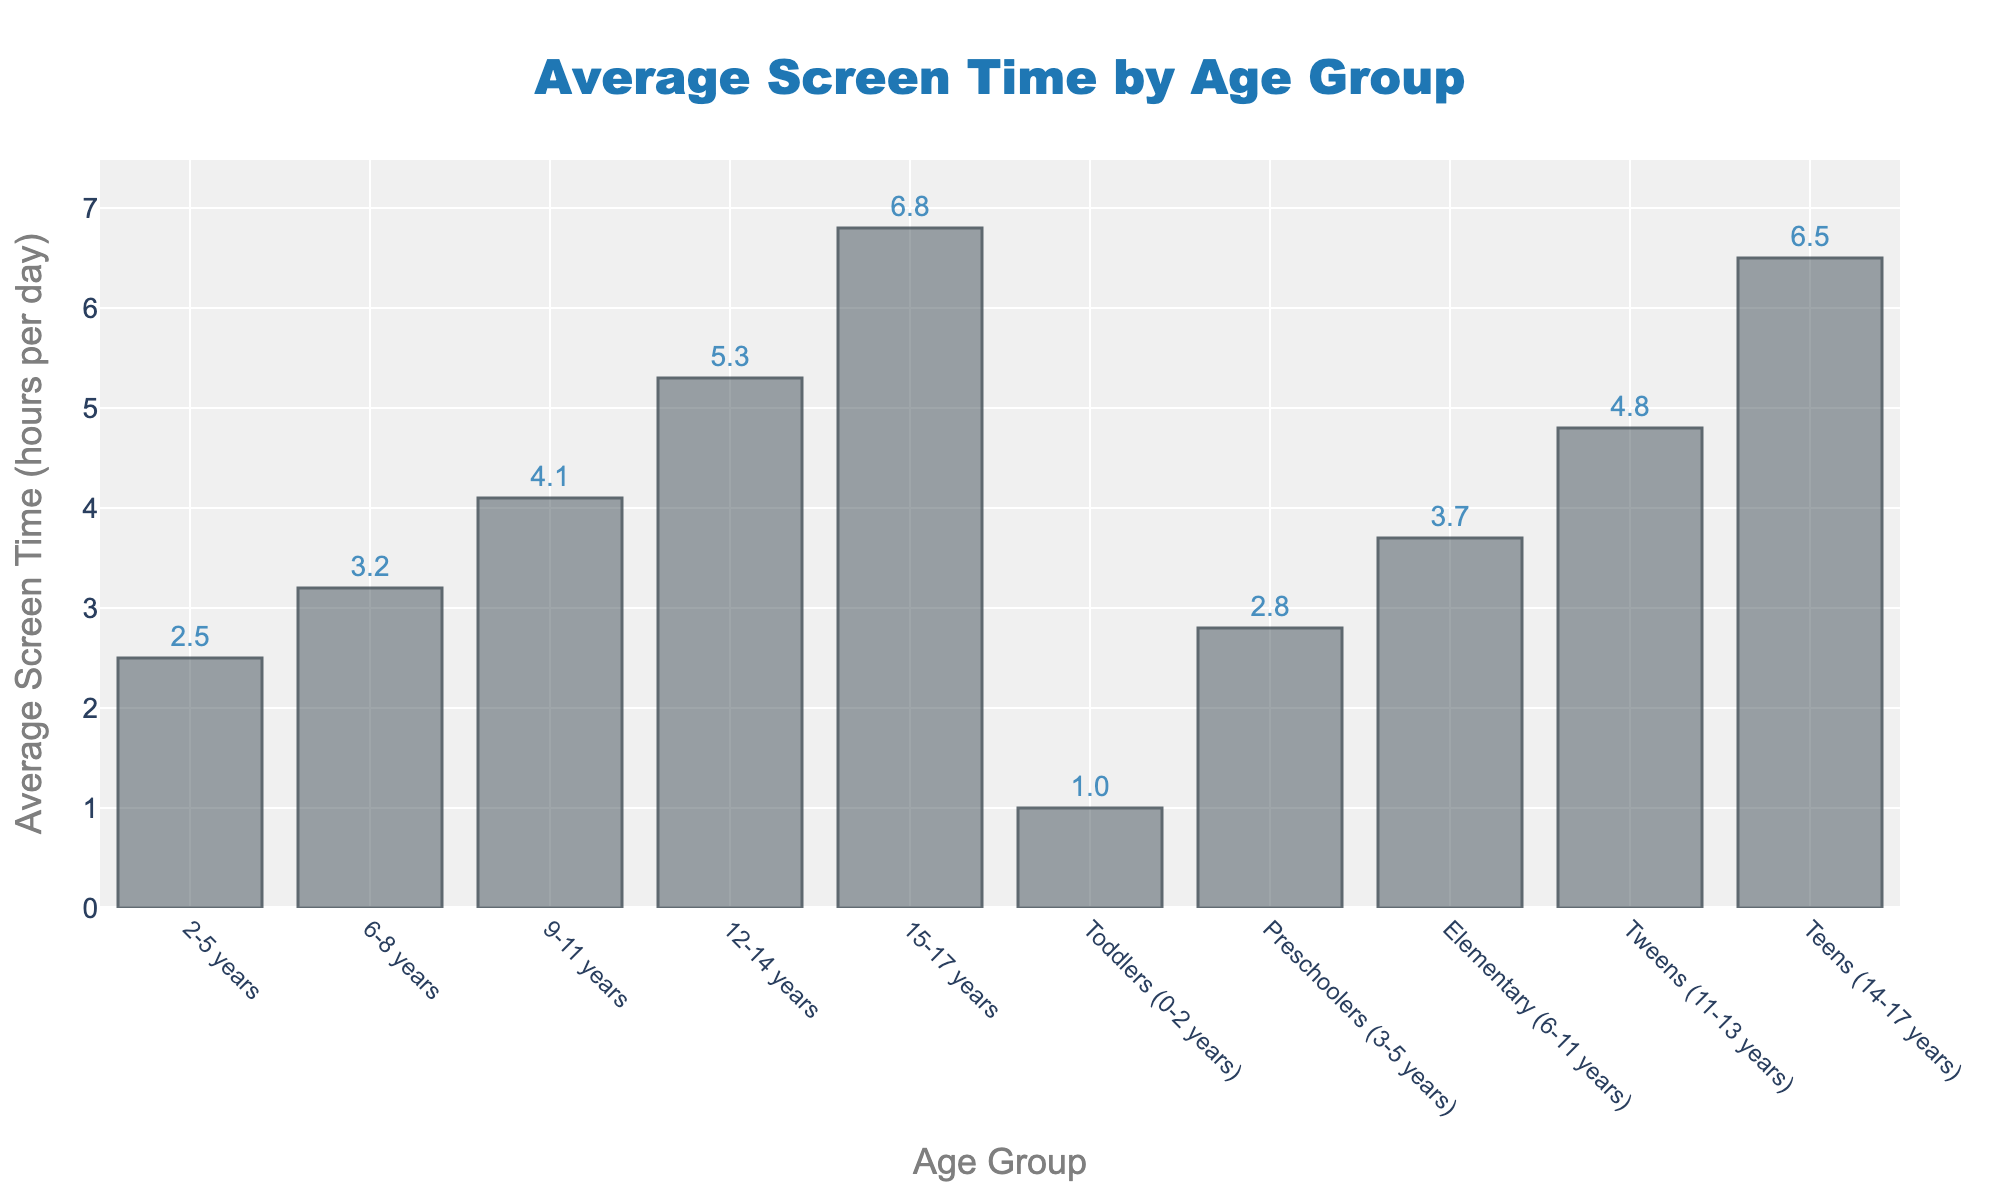What age group has the highest average screen time? By examining the height of the bars in the figure, the tallest bar corresponds to the 15-17 years age group, indicating they have the highest average screen time.
Answer: 15-17 years Which age group has higher screen time, 6-8 years or 9-11 years? By comparing the heights of the bars for the 6-8 years and 9-11 years groups, the 9-11 years group's bar is taller. Thus, the 9-11 years group has higher screen time.
Answer: 9-11 years What is the total average screen time for Preschoolers and Elementary age groups combined? Adding the average screen times for Preschoolers (2.8 hours) and Elementary age groups (3.7 hours) results in 6.5 hours.
Answer: 6.5 hours How much more screen time do Teens (14-17 years) have compared to Toddlers (0-2 years)? The average screen time for Teens is 6.5 hours, and for Toddlers, it is 1.0 hour. Subtracting these gives 6.5 - 1.0 = 5.5 hours.
Answer: 5.5 hours Is the screen time for Tweens (11-13 years) closer to the screen time of 9-11 years or 12-14 years? The average screen time for Tweens is 4.8 hours. Comparing this to 4.1 hours (9-11 years) and 5.3 hours (12-14 years), the difference is smaller with 5.3 hours.
Answer: 12-14 years What is the difference in screen time between the youngest age group (Toddlers) and the oldest age group (15-17 years)? The average screen time for Toddlers is 1.0 hour and for 15-17 years is 6.8 hours. The difference is 6.8 - 1.0 = 5.8 hours.
Answer: 5.8 hours Which age range has the greatest difference in screen time between consecutive groups? Calculate the differences between consecutive age groups: 
 2-5 (2.5), 6-8 (3.2) difference 0.7;
 6-8 (3.2), 9-11 (4.1) difference 0.9;
 9-11 (4.1), 12-14 (5.3) difference 1.2;
 12-14 (5.3), 15-17 (6.8) difference 1.5;
 The greatest difference is between 12-14 and 15-17 years with 1.5 hours.
Answer: 12-14 and 15-17 years If the data were grouped into just three categories: Toddlers+Preschoolers, Elementary+Tweens, and Teens, what would be the average screen time for each group? 1. Toddlers+Preschoolers: Sum of 1.0 + 2.8 = 3.8, which averages to 3.8 / 2 = 1.9 hours. 
 2. Elementary+Tweens: Sum of 3.7 + 4.8 = 8.5, which averages to 8.5 / 2 = 4.25 hours. 
 3. Teens: 6.5 hours.
Answer: 1.9 hours, 4.25 hours, 6.5 hours Which group has the lowest average screen time and by how much is it lower than the next lowest group? Toddlers (0-2 years) have the lowest average screen time at 1.0 hour, which is 1.5 hours lower than the next lowest group, 2-5 years, with 2.5 hours.
Answer: 1.0 hour, 1.5 hours What is the average screen time for all age groups combined? Adding all the average screen times: 2.5 + 3.2 + 4.1 + 5.3 + 6.8 + 1.0 + 2.8 + 3.7 + 4.8 + 6.5 = 40.7 hours. Dividing by the number of groups (10) gives 40.7 / 10 = 4.07 hours.
Answer: 4.07 hours 